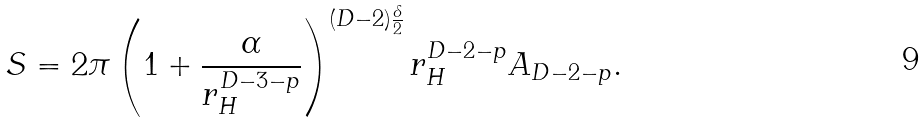Convert formula to latex. <formula><loc_0><loc_0><loc_500><loc_500>S = 2 \pi \left ( 1 + \frac { \alpha } { r _ { H } ^ { D - 3 - p } } \right ) ^ { ( D - 2 ) \frac { \delta } { 2 } } r _ { H } ^ { D - 2 - p } A _ { D - 2 - p } .</formula> 